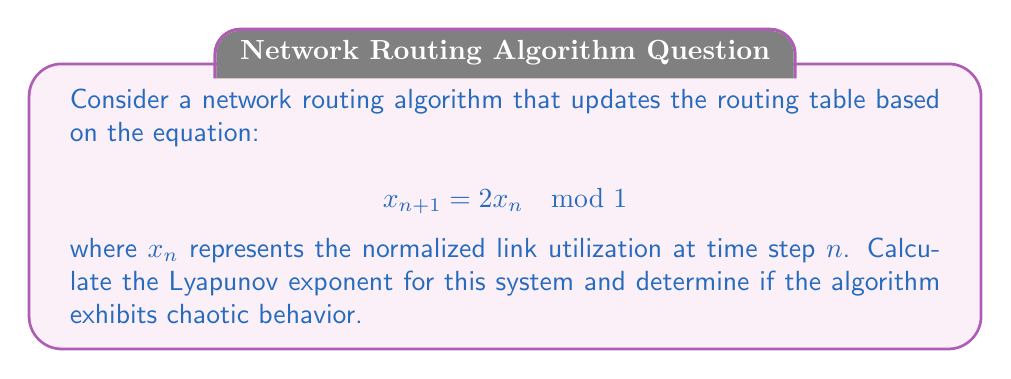Show me your answer to this math problem. To analyze the Lyapunov exponent of this network routing algorithm, we'll follow these steps:

1) The Lyapunov exponent $\lambda$ for a 1D map is given by:

   $$\lambda = \lim_{N \to \infty} \frac{1}{N} \sum_{n=0}^{N-1} \ln |f'(x_n)|$$

   where $f'(x_n)$ is the derivative of the map at point $x_n$.

2) For our map $f(x) = 2x \mod 1$, we need to consider two cases:
   
   Case 1: When $0 \leq x < 0.5$, $f(x) = 2x$
   Case 2: When $0.5 \leq x < 1$, $f(x) = 2x - 1$

3) The derivative $f'(x)$ is 2 for both cases.

4) Substituting into the Lyapunov exponent formula:

   $$\lambda = \lim_{N \to \infty} \frac{1}{N} \sum_{n=0}^{N-1} \ln |2|$$

5) Simplify:

   $$\lambda = \lim_{N \to \infty} \frac{1}{N} \cdot N \ln |2| = \ln 2 \approx 0.693$$

6) Since $\lambda > 0$, the system exhibits chaotic behavior. This means that small changes in initial conditions can lead to significantly different outcomes in the routing algorithm's behavior over time.

7) In the context of network engineering, this implies that the routing algorithm is sensitive to initial conditions and may lead to unpredictable network traffic patterns, potentially causing congestion or suboptimal routing decisions.
Answer: $\lambda = \ln 2 \approx 0.693$; chaotic behavior 